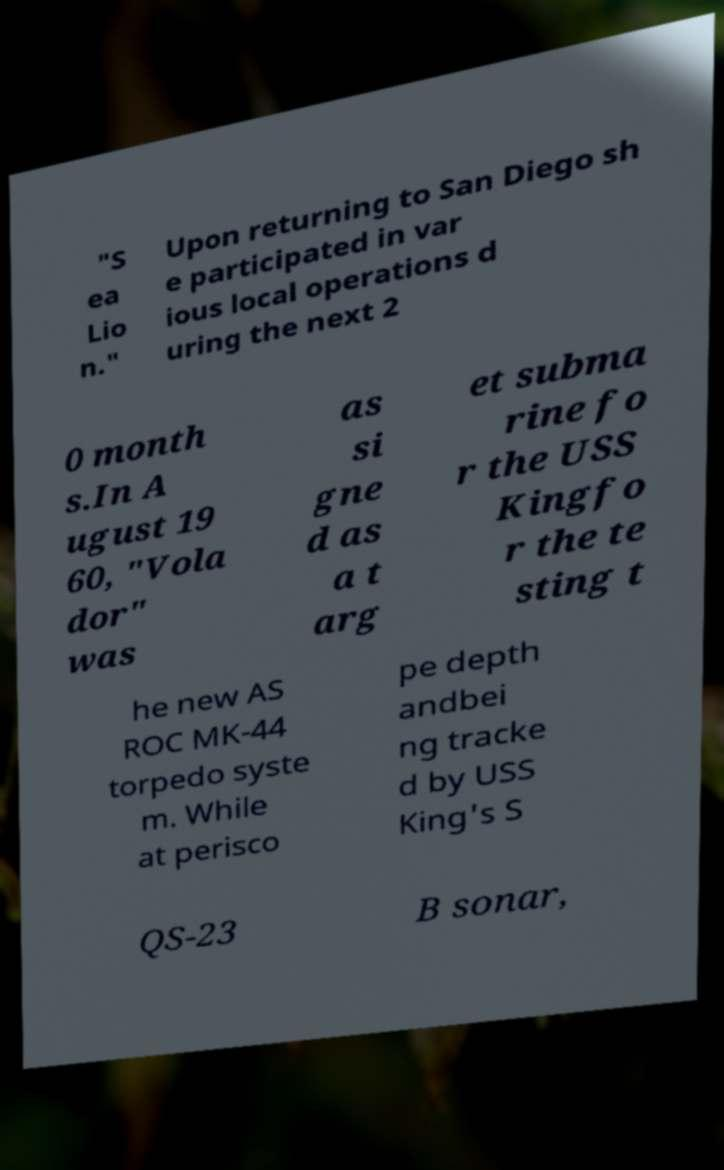For documentation purposes, I need the text within this image transcribed. Could you provide that? "S ea Lio n." Upon returning to San Diego sh e participated in var ious local operations d uring the next 2 0 month s.In A ugust 19 60, "Vola dor" was as si gne d as a t arg et subma rine fo r the USS Kingfo r the te sting t he new AS ROC MK-44 torpedo syste m. While at perisco pe depth andbei ng tracke d by USS King's S QS-23 B sonar, 